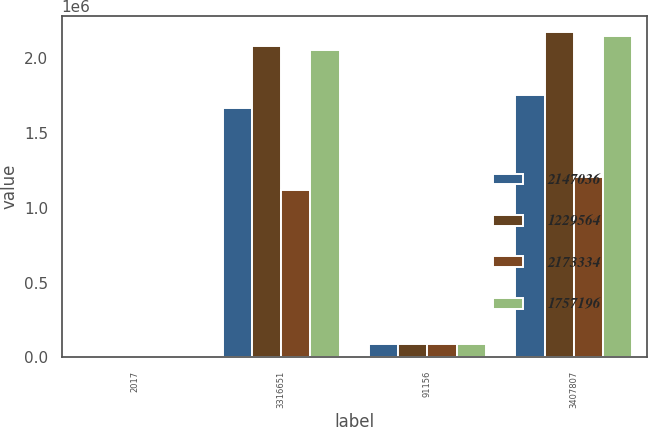<chart> <loc_0><loc_0><loc_500><loc_500><stacked_bar_chart><ecel><fcel>2017<fcel>3316651<fcel>91156<fcel>3407807<nl><fcel>2.14704e+06<fcel>2017<fcel>1.66604e+06<fcel>91156<fcel>1.7572e+06<nl><fcel>1.22956e+06<fcel>2016<fcel>2.08421e+06<fcel>89124<fcel>2.17333e+06<nl><fcel>2.17333e+06<fcel>2016<fcel>1.11634e+06<fcel>89124<fcel>1.20546e+06<nl><fcel>1.7572e+06<fcel>2015<fcel>2.05744e+06<fcel>89593<fcel>2.14704e+06<nl></chart> 